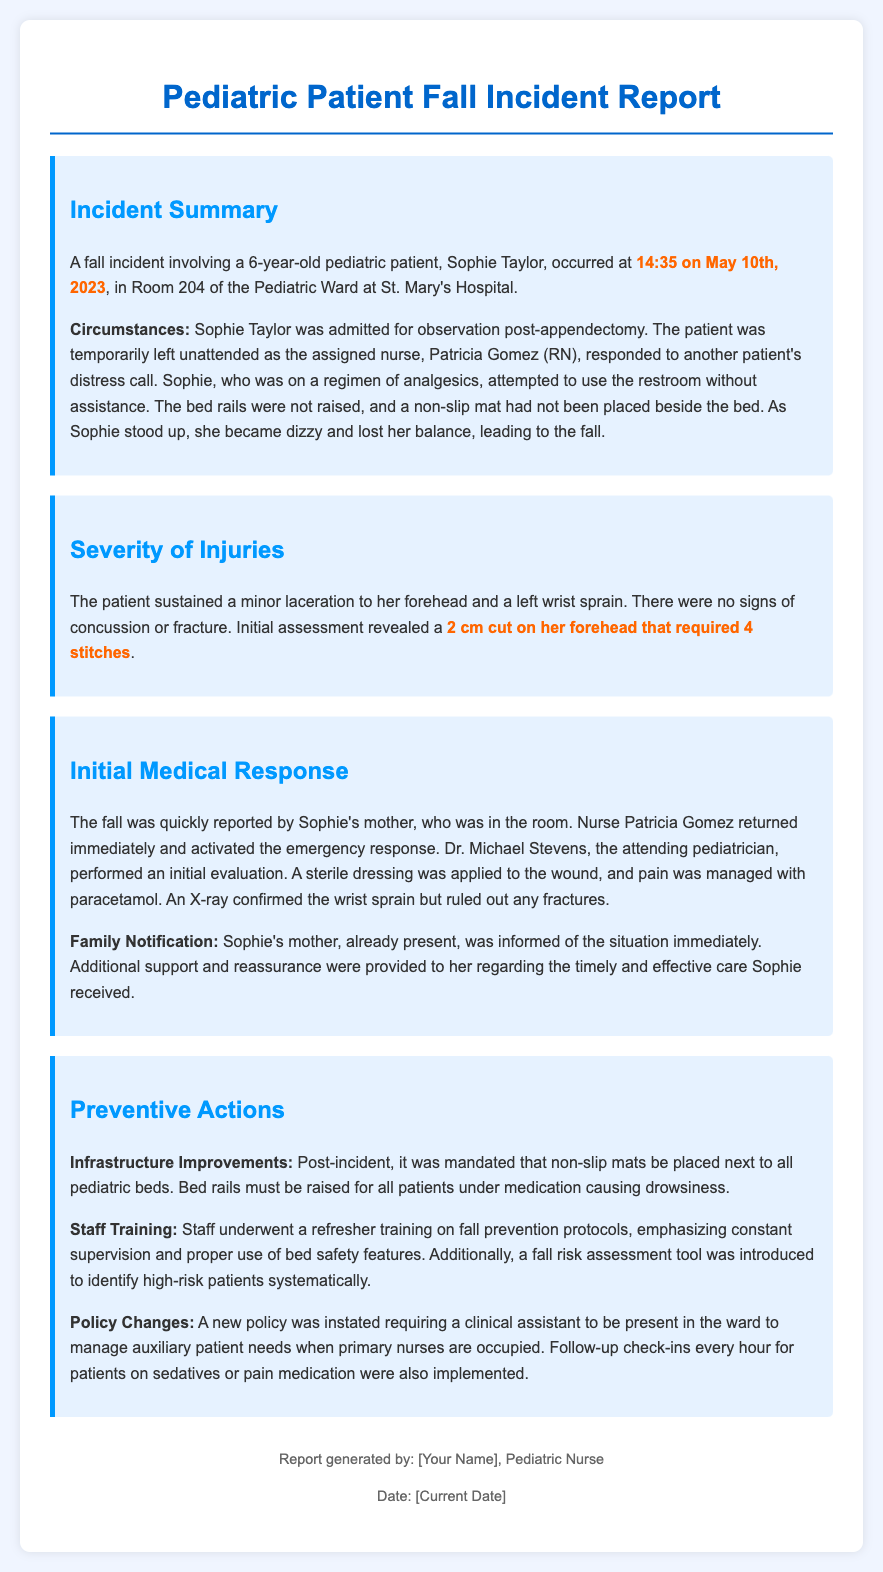What was the patient's name? The patient's name, as mentioned in the report, is Sophie Taylor.
Answer: Sophie Taylor What time did the incident occur? The report specifies that the incident occurred at 14:35 on May 10th, 2023.
Answer: 14:35 on May 10th, 2023 What was the significant medical intervention performed on the patient's forehead? The report states that a 2 cm cut on her forehead required 4 stitches.
Answer: 4 stitches Who was responsible for the initial medical response? The attending pediatrician who performed the initial evaluation was Dr. Michael Stevens.
Answer: Dr. Michael Stevens What type of injury did Sophie sustain to her wrist? The document indicates that Sophie sustained a left wrist sprain.
Answer: Left wrist sprain What preventive action was mandated for pediatric beds post-incident? The report mandates that non-slip mats be placed next to all pediatric beds.
Answer: Non-slip mats What training was provided to the staff after the incident? Staff underwent refresher training on fall prevention protocols.
Answer: Fall prevention protocols What new policy was instituted for clinical staff presence? A new policy was instated requiring a clinical assistant to be present in the ward.
Answer: Clinical assistant How often are follow-up check-ins required for patients on sedatives? The document mentions that follow-up check-ins are implemented every hour.
Answer: Every hour 